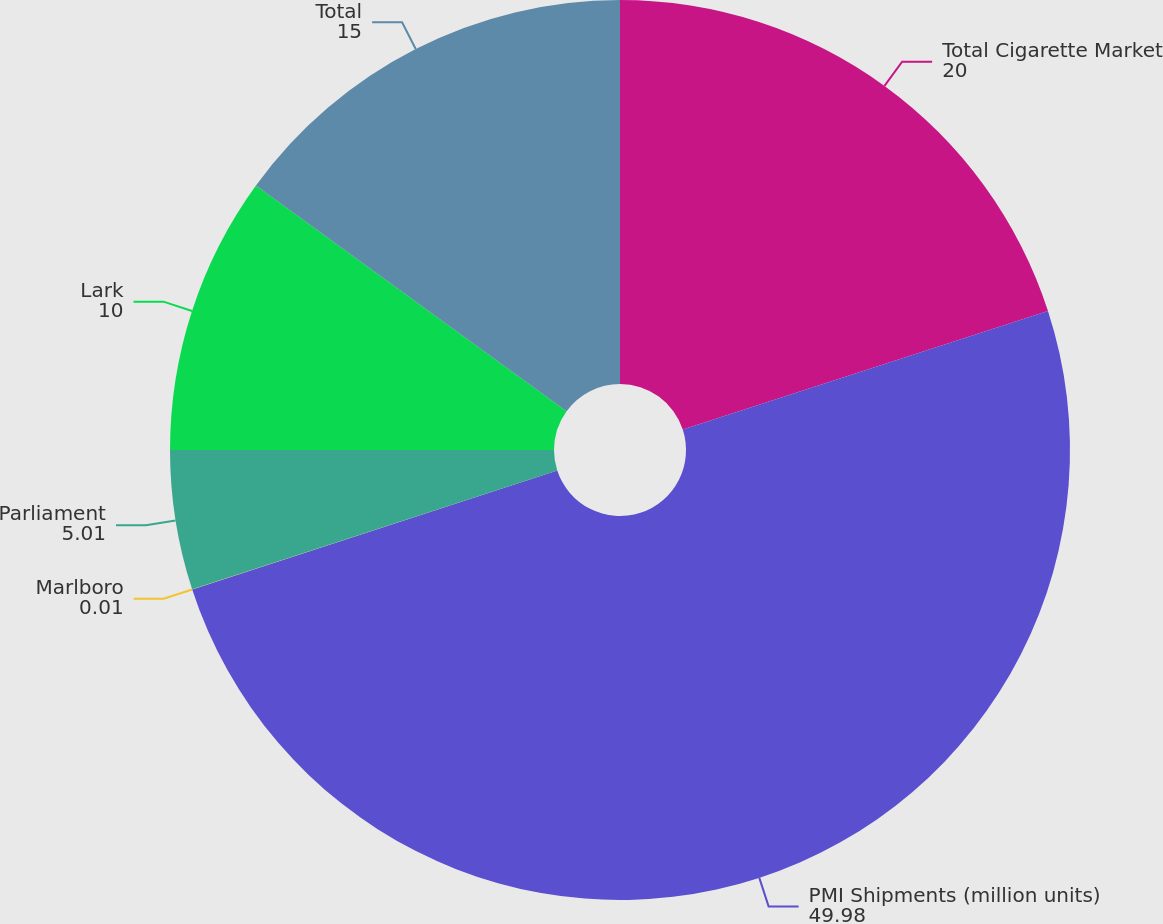<chart> <loc_0><loc_0><loc_500><loc_500><pie_chart><fcel>Total Cigarette Market<fcel>PMI Shipments (million units)<fcel>Marlboro<fcel>Parliament<fcel>Lark<fcel>Total<nl><fcel>20.0%<fcel>49.98%<fcel>0.01%<fcel>5.01%<fcel>10.0%<fcel>15.0%<nl></chart> 